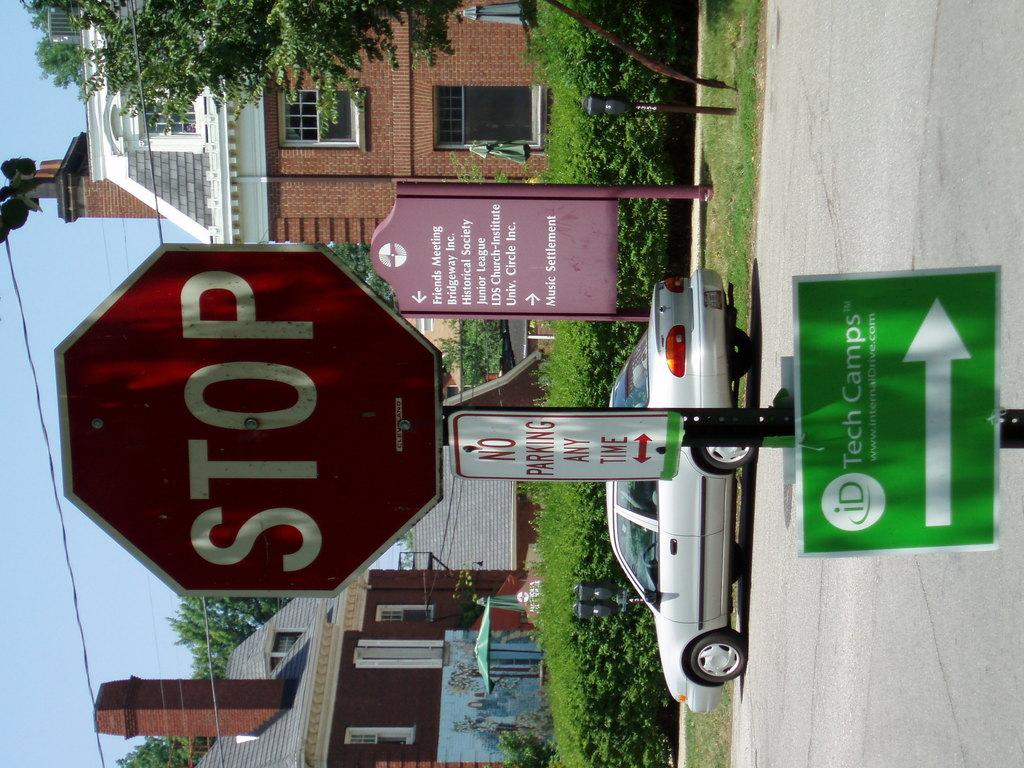<image>
Write a terse but informative summary of the picture. a stop sign and no parking any time sign as you approach the id tech camp 